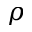Convert formula to latex. <formula><loc_0><loc_0><loc_500><loc_500>\rho</formula> 